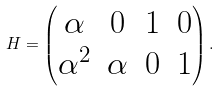Convert formula to latex. <formula><loc_0><loc_0><loc_500><loc_500>H = \begin{pmatrix} \alpha & 0 & 1 & 0 \\ \alpha ^ { 2 } & \alpha & 0 & 1 \end{pmatrix} .</formula> 